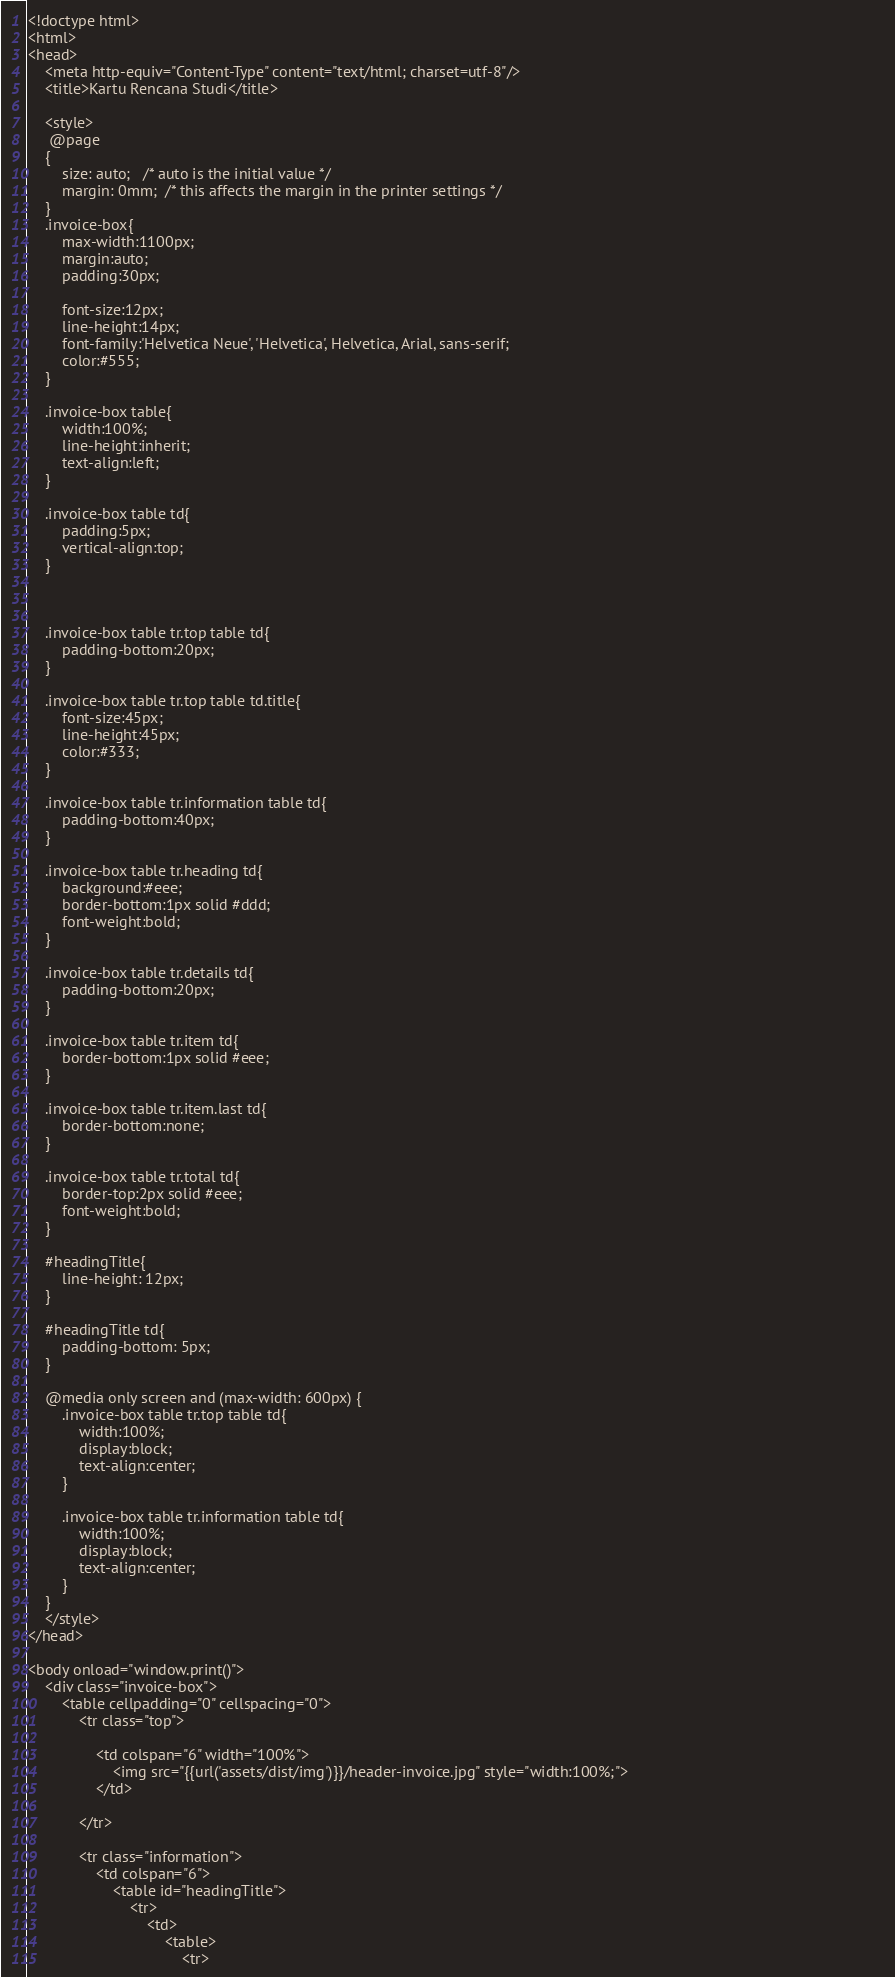<code> <loc_0><loc_0><loc_500><loc_500><_PHP_><!doctype html>
<html>
<head>
    <meta http-equiv="Content-Type" content="text/html; charset=utf-8"/>
    <title>Kartu Rencana Studi</title>
    
    <style>
     @page 
    {
        size: auto;   /* auto is the initial value */
        margin: 0mm;  /* this affects the margin in the printer settings */
    }
    .invoice-box{
        max-width:1100px;
        margin:auto;
        padding:30px;
        
        font-size:12px;
        line-height:14px;
        font-family:'Helvetica Neue', 'Helvetica', Helvetica, Arial, sans-serif;
        color:#555;
    }
    
    .invoice-box table{
        width:100%;
        line-height:inherit;
        text-align:left;
    }
    
    .invoice-box table td{
        padding:5px;
        vertical-align:top;
    }
    
    
    
    .invoice-box table tr.top table td{
        padding-bottom:20px;
    }
    
    .invoice-box table tr.top table td.title{
        font-size:45px;
        line-height:45px;
        color:#333;
    }
    
    .invoice-box table tr.information table td{
        padding-bottom:40px;
    }
    
    .invoice-box table tr.heading td{
        background:#eee;
        border-bottom:1px solid #ddd;
        font-weight:bold;
    }
    
    .invoice-box table tr.details td{
        padding-bottom:20px;
    }
    
    .invoice-box table tr.item td{
        border-bottom:1px solid #eee;
    }
    
    .invoice-box table tr.item.last td{
        border-bottom:none;
    }
    
    .invoice-box table tr.total td{
        border-top:2px solid #eee;
        font-weight:bold;
    }

    #headingTitle{
        line-height: 12px;
    }

    #headingTitle td{
        padding-bottom: 5px;
    }
    
    @media only screen and (max-width: 600px) {
        .invoice-box table tr.top table td{
            width:100%;
            display:block;
            text-align:center;
        }
        
        .invoice-box table tr.information table td{
            width:100%;
            display:block;
            text-align:center;
        }
    }
    </style>
</head>

<body onload="window.print()">
    <div class="invoice-box">
        <table cellpadding="0" cellspacing="0">
            <tr class="top">
                
                <td colspan="6" width="100%">
                    <img src="{{url('assets/dist/img')}}/header-invoice.jpg" style="width:100%;">                                                            
                </td>
                   
            </tr>
            
            <tr class="information">
                <td colspan="6">
                    <table id="headingTitle">
                        <tr>
                            <td>
                                <table>
                                    <tr>                      </code> 